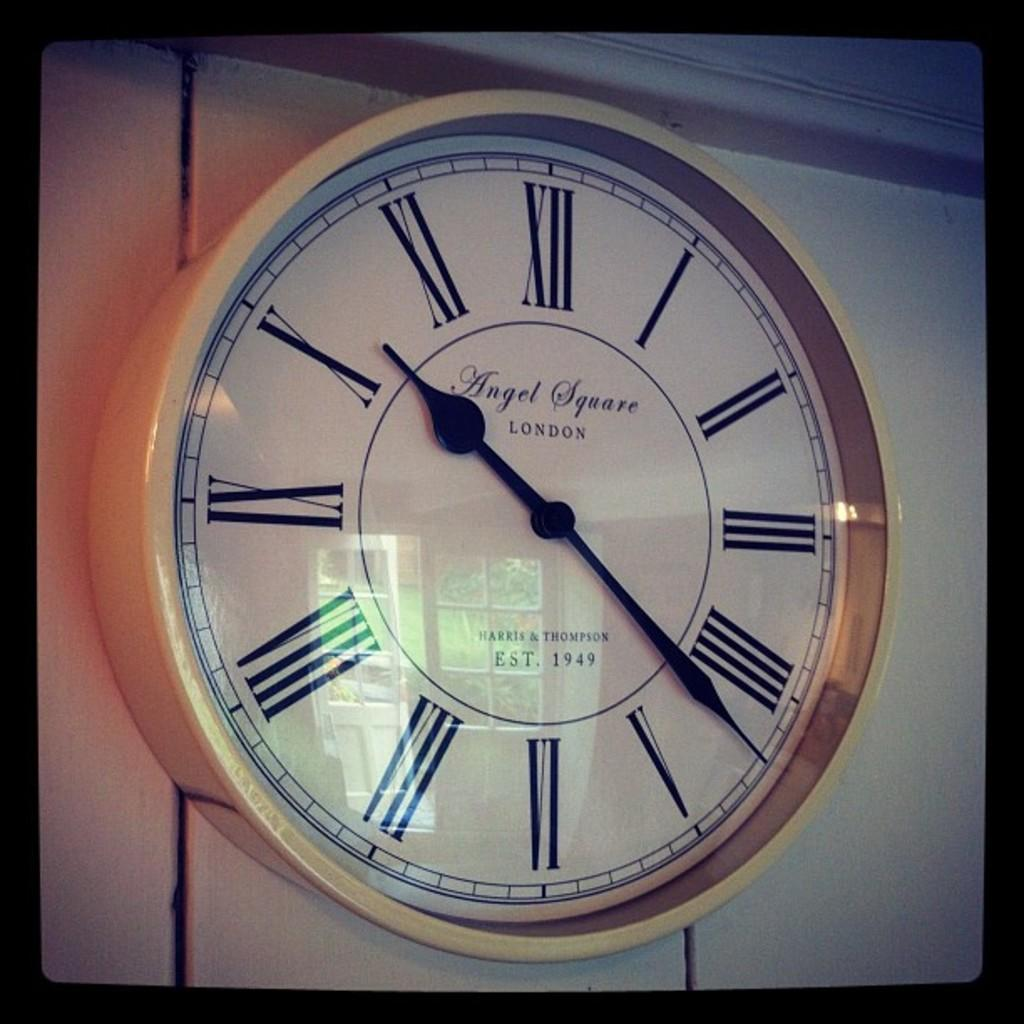<image>
Share a concise interpretation of the image provided. A large clock by Harris and Thompson displays a time of 10:22. 